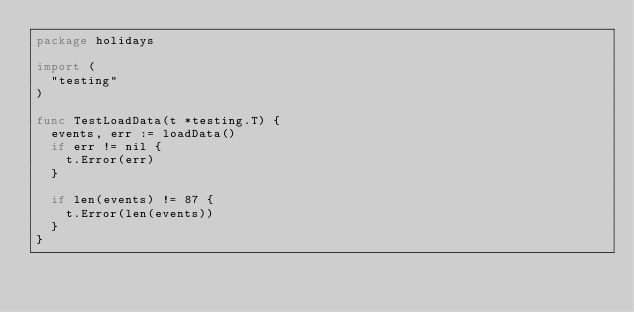Convert code to text. <code><loc_0><loc_0><loc_500><loc_500><_Go_>package holidays

import (
	"testing"
)

func TestLoadData(t *testing.T) {
	events, err := loadData()
	if err != nil {
		t.Error(err)
	}

	if len(events) != 87 {
		t.Error(len(events))
	}
}
</code> 